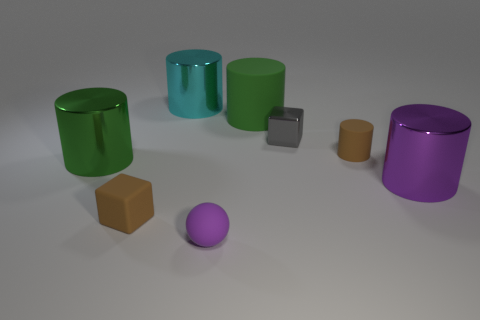What can you tell me about the lighting and shadows in the scene? The lighting in the scene comes from above, casting soft shadows directly beneath the objects. The shadows are gentle and elongated, suggesting that the light source, while strong enough to well-illuminate the scene, is not overly harsh. It creates a diffused and calm atmosphere with no sharp contrasts. The shadows can also help us understand the spatial arrangement of the objects, inferring that they are resting on a flat surface. 